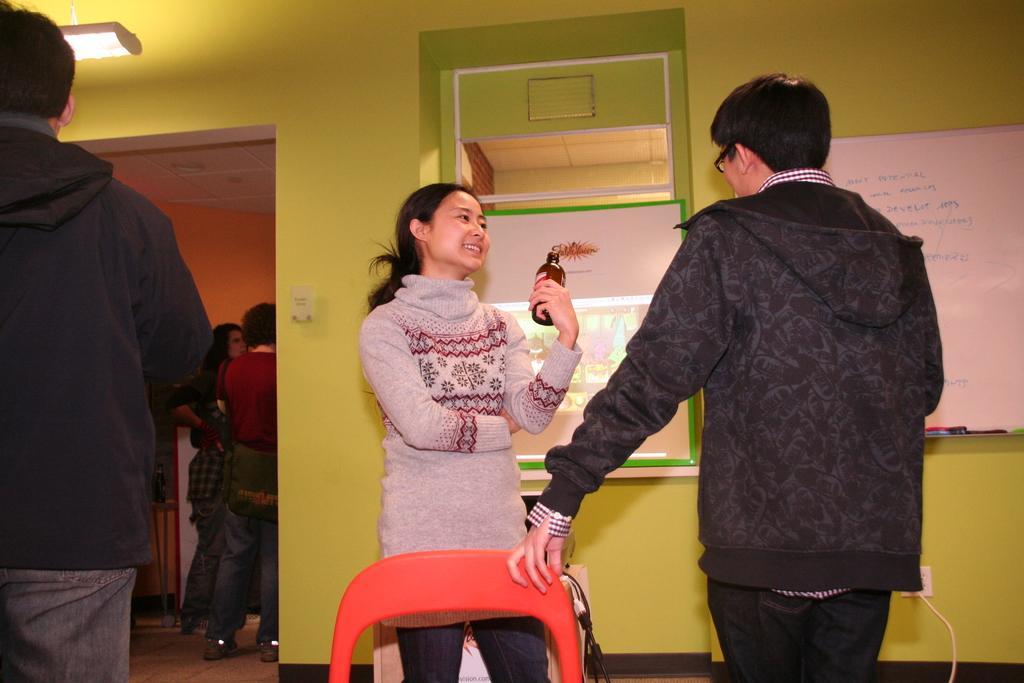Describe this image in one or two sentences. On the left side of the image we can see a person is standing. In the middle of the image we can see a lady is standing and holding a bottle in her hand. On the right side of the image we can see a person is standing and a board is there. 